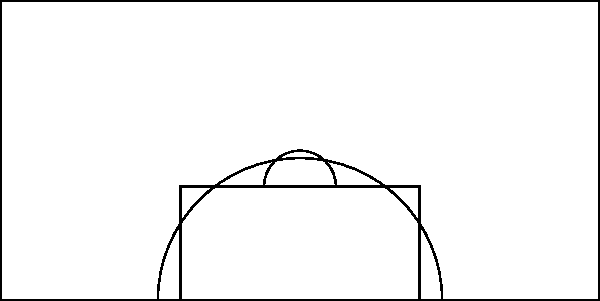Based on the player heat map shown in the half-court diagram, which area should our team focus on to gain a rebounding advantage against this opponent? To determine the best area for rebounding advantage, we need to analyze the heat map:

1. The heat map is divided into a 5x5 grid, with red intensity indicating player presence.
2. Darker red areas show higher player concentration.
3. The most intense area is in the center of the key (value 4).
4. There's a high concentration just outside the key on both sides (value 3).
5. The area directly under the basket has relatively low presence (value 1).
6. The corners and wings show minimal player presence.

Given this information:
1. The opponent's players are concentrated in and around the key.
2. There's a noticeable lack of presence directly under the basket.
3. The corners and wings are largely unoccupied.

For optimal rebounding positioning:
1. We should position our players where the opponent is least present.
2. The area directly under the basket is crucial for rebounds and lightly defended.
3. The corners and wings offer opportunities for long rebounds on missed shots.

Therefore, to gain a rebounding advantage, we should focus on positioning our players directly under the basket and in the corners/wings. This strategy takes advantage of the opponent's positioning weakness and increases our chances of securing rebounds.
Answer: Directly under the basket and corners/wings 